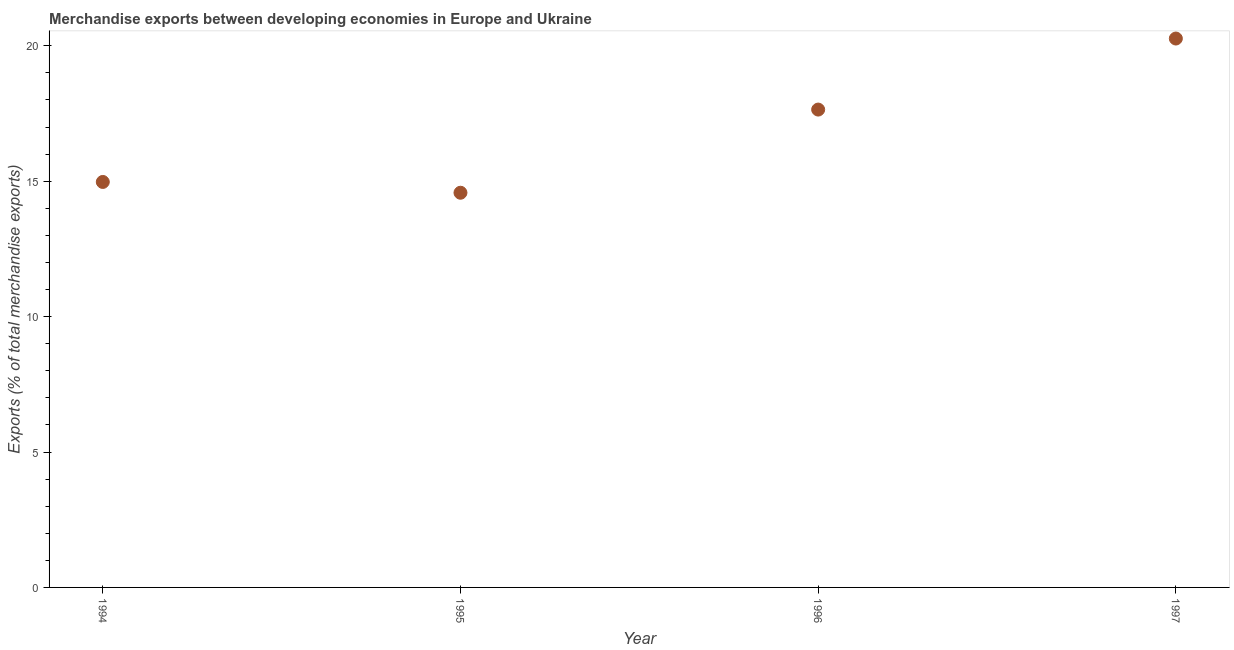What is the merchandise exports in 1996?
Make the answer very short. 17.64. Across all years, what is the maximum merchandise exports?
Your response must be concise. 20.27. Across all years, what is the minimum merchandise exports?
Provide a short and direct response. 14.57. In which year was the merchandise exports maximum?
Offer a very short reply. 1997. In which year was the merchandise exports minimum?
Give a very brief answer. 1995. What is the sum of the merchandise exports?
Ensure brevity in your answer.  67.45. What is the difference between the merchandise exports in 1996 and 1997?
Make the answer very short. -2.62. What is the average merchandise exports per year?
Provide a short and direct response. 16.86. What is the median merchandise exports?
Your response must be concise. 16.31. Do a majority of the years between 1995 and 1996 (inclusive) have merchandise exports greater than 18 %?
Keep it short and to the point. No. What is the ratio of the merchandise exports in 1994 to that in 1996?
Your answer should be compact. 0.85. Is the merchandise exports in 1996 less than that in 1997?
Offer a very short reply. Yes. Is the difference between the merchandise exports in 1994 and 1995 greater than the difference between any two years?
Offer a terse response. No. What is the difference between the highest and the second highest merchandise exports?
Make the answer very short. 2.62. Is the sum of the merchandise exports in 1994 and 1997 greater than the maximum merchandise exports across all years?
Your answer should be compact. Yes. What is the difference between the highest and the lowest merchandise exports?
Provide a short and direct response. 5.69. In how many years, is the merchandise exports greater than the average merchandise exports taken over all years?
Provide a succinct answer. 2. How many years are there in the graph?
Your answer should be compact. 4. What is the difference between two consecutive major ticks on the Y-axis?
Keep it short and to the point. 5. Does the graph contain grids?
Your answer should be compact. No. What is the title of the graph?
Your answer should be compact. Merchandise exports between developing economies in Europe and Ukraine. What is the label or title of the Y-axis?
Your answer should be very brief. Exports (% of total merchandise exports). What is the Exports (% of total merchandise exports) in 1994?
Ensure brevity in your answer.  14.97. What is the Exports (% of total merchandise exports) in 1995?
Make the answer very short. 14.57. What is the Exports (% of total merchandise exports) in 1996?
Make the answer very short. 17.64. What is the Exports (% of total merchandise exports) in 1997?
Your answer should be compact. 20.27. What is the difference between the Exports (% of total merchandise exports) in 1994 and 1995?
Provide a short and direct response. 0.4. What is the difference between the Exports (% of total merchandise exports) in 1994 and 1996?
Offer a very short reply. -2.67. What is the difference between the Exports (% of total merchandise exports) in 1994 and 1997?
Ensure brevity in your answer.  -5.3. What is the difference between the Exports (% of total merchandise exports) in 1995 and 1996?
Your answer should be very brief. -3.07. What is the difference between the Exports (% of total merchandise exports) in 1995 and 1997?
Your answer should be compact. -5.69. What is the difference between the Exports (% of total merchandise exports) in 1996 and 1997?
Your answer should be compact. -2.62. What is the ratio of the Exports (% of total merchandise exports) in 1994 to that in 1995?
Keep it short and to the point. 1.03. What is the ratio of the Exports (% of total merchandise exports) in 1994 to that in 1996?
Offer a terse response. 0.85. What is the ratio of the Exports (% of total merchandise exports) in 1994 to that in 1997?
Make the answer very short. 0.74. What is the ratio of the Exports (% of total merchandise exports) in 1995 to that in 1996?
Offer a terse response. 0.83. What is the ratio of the Exports (% of total merchandise exports) in 1995 to that in 1997?
Offer a terse response. 0.72. What is the ratio of the Exports (% of total merchandise exports) in 1996 to that in 1997?
Ensure brevity in your answer.  0.87. 